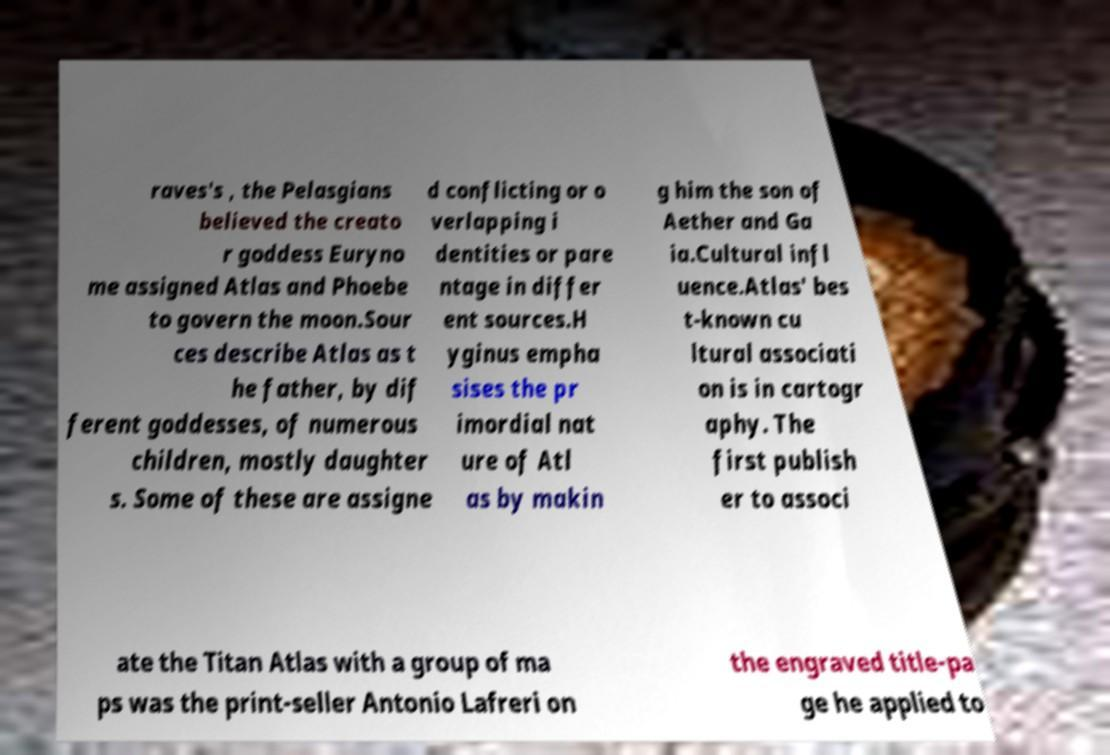I need the written content from this picture converted into text. Can you do that? raves's , the Pelasgians believed the creato r goddess Euryno me assigned Atlas and Phoebe to govern the moon.Sour ces describe Atlas as t he father, by dif ferent goddesses, of numerous children, mostly daughter s. Some of these are assigne d conflicting or o verlapping i dentities or pare ntage in differ ent sources.H yginus empha sises the pr imordial nat ure of Atl as by makin g him the son of Aether and Ga ia.Cultural infl uence.Atlas' bes t-known cu ltural associati on is in cartogr aphy. The first publish er to associ ate the Titan Atlas with a group of ma ps was the print-seller Antonio Lafreri on the engraved title-pa ge he applied to 